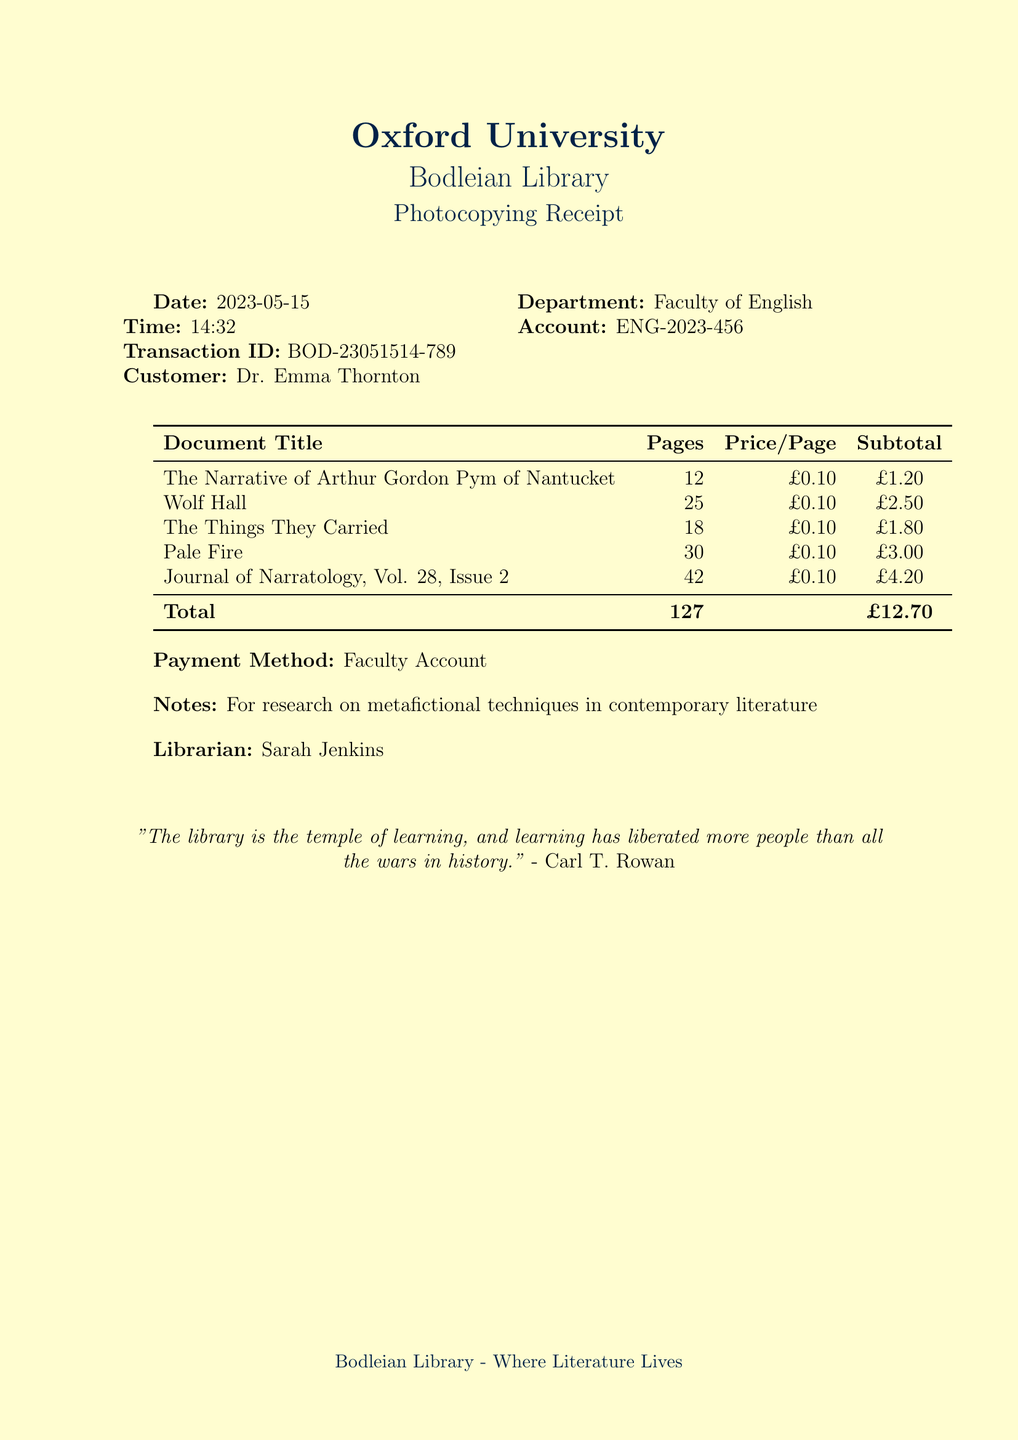what is the date of the transaction? The date of the transaction is listed in the document as the day when the photocopying services were used.
Answer: 2023-05-15 who is the customer? The customer name is provided in the receipt, indicating the individual who requested the photocopying services.
Answer: Dr. Emma Thornton how many pages were photocopied in total? The total number of pages is calculated from the individual documents listed in the receipt, summing them up.
Answer: 127 what is the total cost of the photocopying? The total cost is provided as part of the payment details within the receipt.
Answer: £12.70 what is the title of the first document listed? The first document in the itemized list indicates the specified title that was photocopied.
Answer: The Narrative of Arthur Gordon Pym of Nantucket by Edgar Allan Poe how many pages does "Wolf Hall" have? The number of pages for "Wolf Hall" is specified alongside the title in the document.
Answer: 25 who was the librarian involved in this transaction? The librarian's name is mentioned as the person who assisted or processed the transaction.
Answer: Sarah Jenkins what payment method was used for the transaction? The payment method is explicitly stated in the receipt to indicate how the cost was settled.
Answer: Faculty Account what is the purpose of the photocopying as noted in the document? The purpose of the photocopying services used is written in a note section indicating the research theme.
Answer: For research on metafictional techniques in contemporary literature 